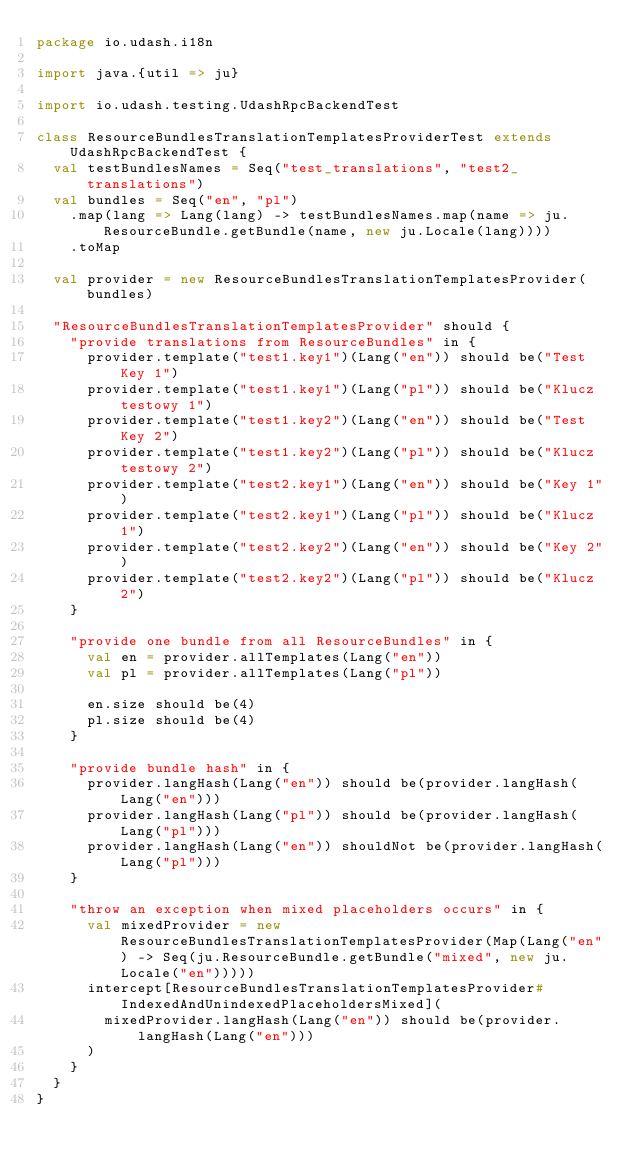<code> <loc_0><loc_0><loc_500><loc_500><_Scala_>package io.udash.i18n

import java.{util => ju}

import io.udash.testing.UdashRpcBackendTest

class ResourceBundlesTranslationTemplatesProviderTest extends UdashRpcBackendTest {
  val testBundlesNames = Seq("test_translations", "test2_translations")
  val bundles = Seq("en", "pl")
    .map(lang => Lang(lang) -> testBundlesNames.map(name => ju.ResourceBundle.getBundle(name, new ju.Locale(lang))))
    .toMap

  val provider = new ResourceBundlesTranslationTemplatesProvider(bundles)

  "ResourceBundlesTranslationTemplatesProvider" should {
    "provide translations from ResourceBundles" in {
      provider.template("test1.key1")(Lang("en")) should be("Test Key 1")
      provider.template("test1.key1")(Lang("pl")) should be("Klucz testowy 1")
      provider.template("test1.key2")(Lang("en")) should be("Test Key 2")
      provider.template("test1.key2")(Lang("pl")) should be("Klucz testowy 2")
      provider.template("test2.key1")(Lang("en")) should be("Key 1")
      provider.template("test2.key1")(Lang("pl")) should be("Klucz 1")
      provider.template("test2.key2")(Lang("en")) should be("Key 2")
      provider.template("test2.key2")(Lang("pl")) should be("Klucz 2")
    }

    "provide one bundle from all ResourceBundles" in {
      val en = provider.allTemplates(Lang("en"))
      val pl = provider.allTemplates(Lang("pl"))

      en.size should be(4)
      pl.size should be(4)
    }

    "provide bundle hash" in {
      provider.langHash(Lang("en")) should be(provider.langHash(Lang("en")))
      provider.langHash(Lang("pl")) should be(provider.langHash(Lang("pl")))
      provider.langHash(Lang("en")) shouldNot be(provider.langHash(Lang("pl")))
    }

    "throw an exception when mixed placeholders occurs" in {
      val mixedProvider = new ResourceBundlesTranslationTemplatesProvider(Map(Lang("en") -> Seq(ju.ResourceBundle.getBundle("mixed", new ju.Locale("en")))))
      intercept[ResourceBundlesTranslationTemplatesProvider#IndexedAndUnindexedPlaceholdersMixed](
        mixedProvider.langHash(Lang("en")) should be(provider.langHash(Lang("en")))
      )
    }
  }
}
</code> 